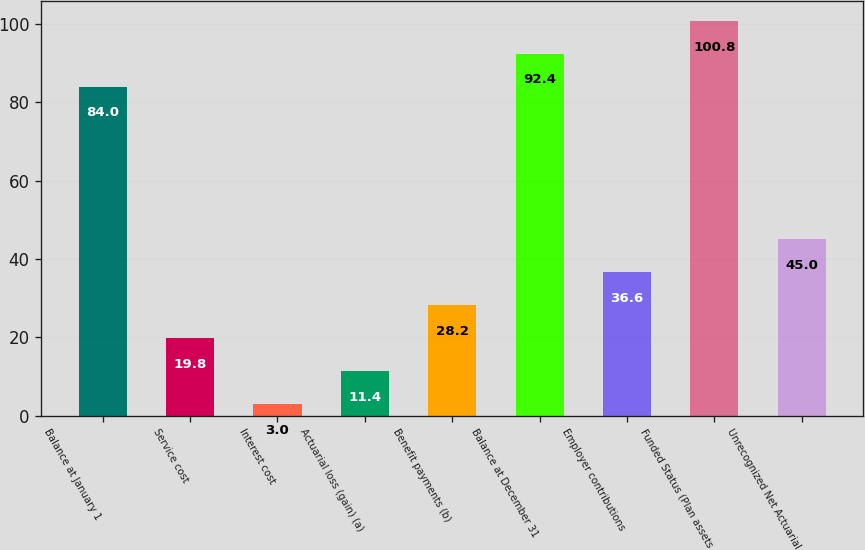Convert chart. <chart><loc_0><loc_0><loc_500><loc_500><bar_chart><fcel>Balance at January 1<fcel>Service cost<fcel>Interest cost<fcel>Actuarial loss (gain) (a)<fcel>Benefit payments (b)<fcel>Balance at December 31<fcel>Employer contributions<fcel>Funded Status (Plan assets<fcel>Unrecognized Net Actuarial<nl><fcel>84<fcel>19.8<fcel>3<fcel>11.4<fcel>28.2<fcel>92.4<fcel>36.6<fcel>100.8<fcel>45<nl></chart> 